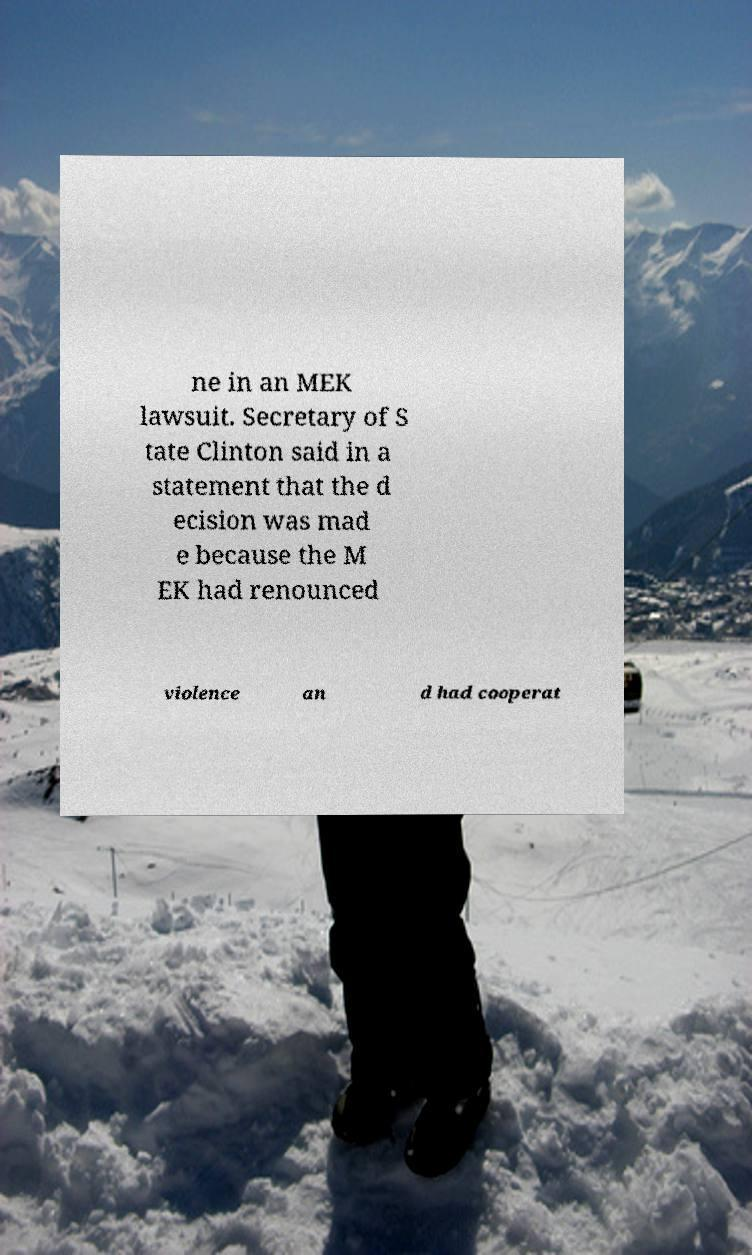For documentation purposes, I need the text within this image transcribed. Could you provide that? ne in an MEK lawsuit. Secretary of S tate Clinton said in a statement that the d ecision was mad e because the M EK had renounced violence an d had cooperat 